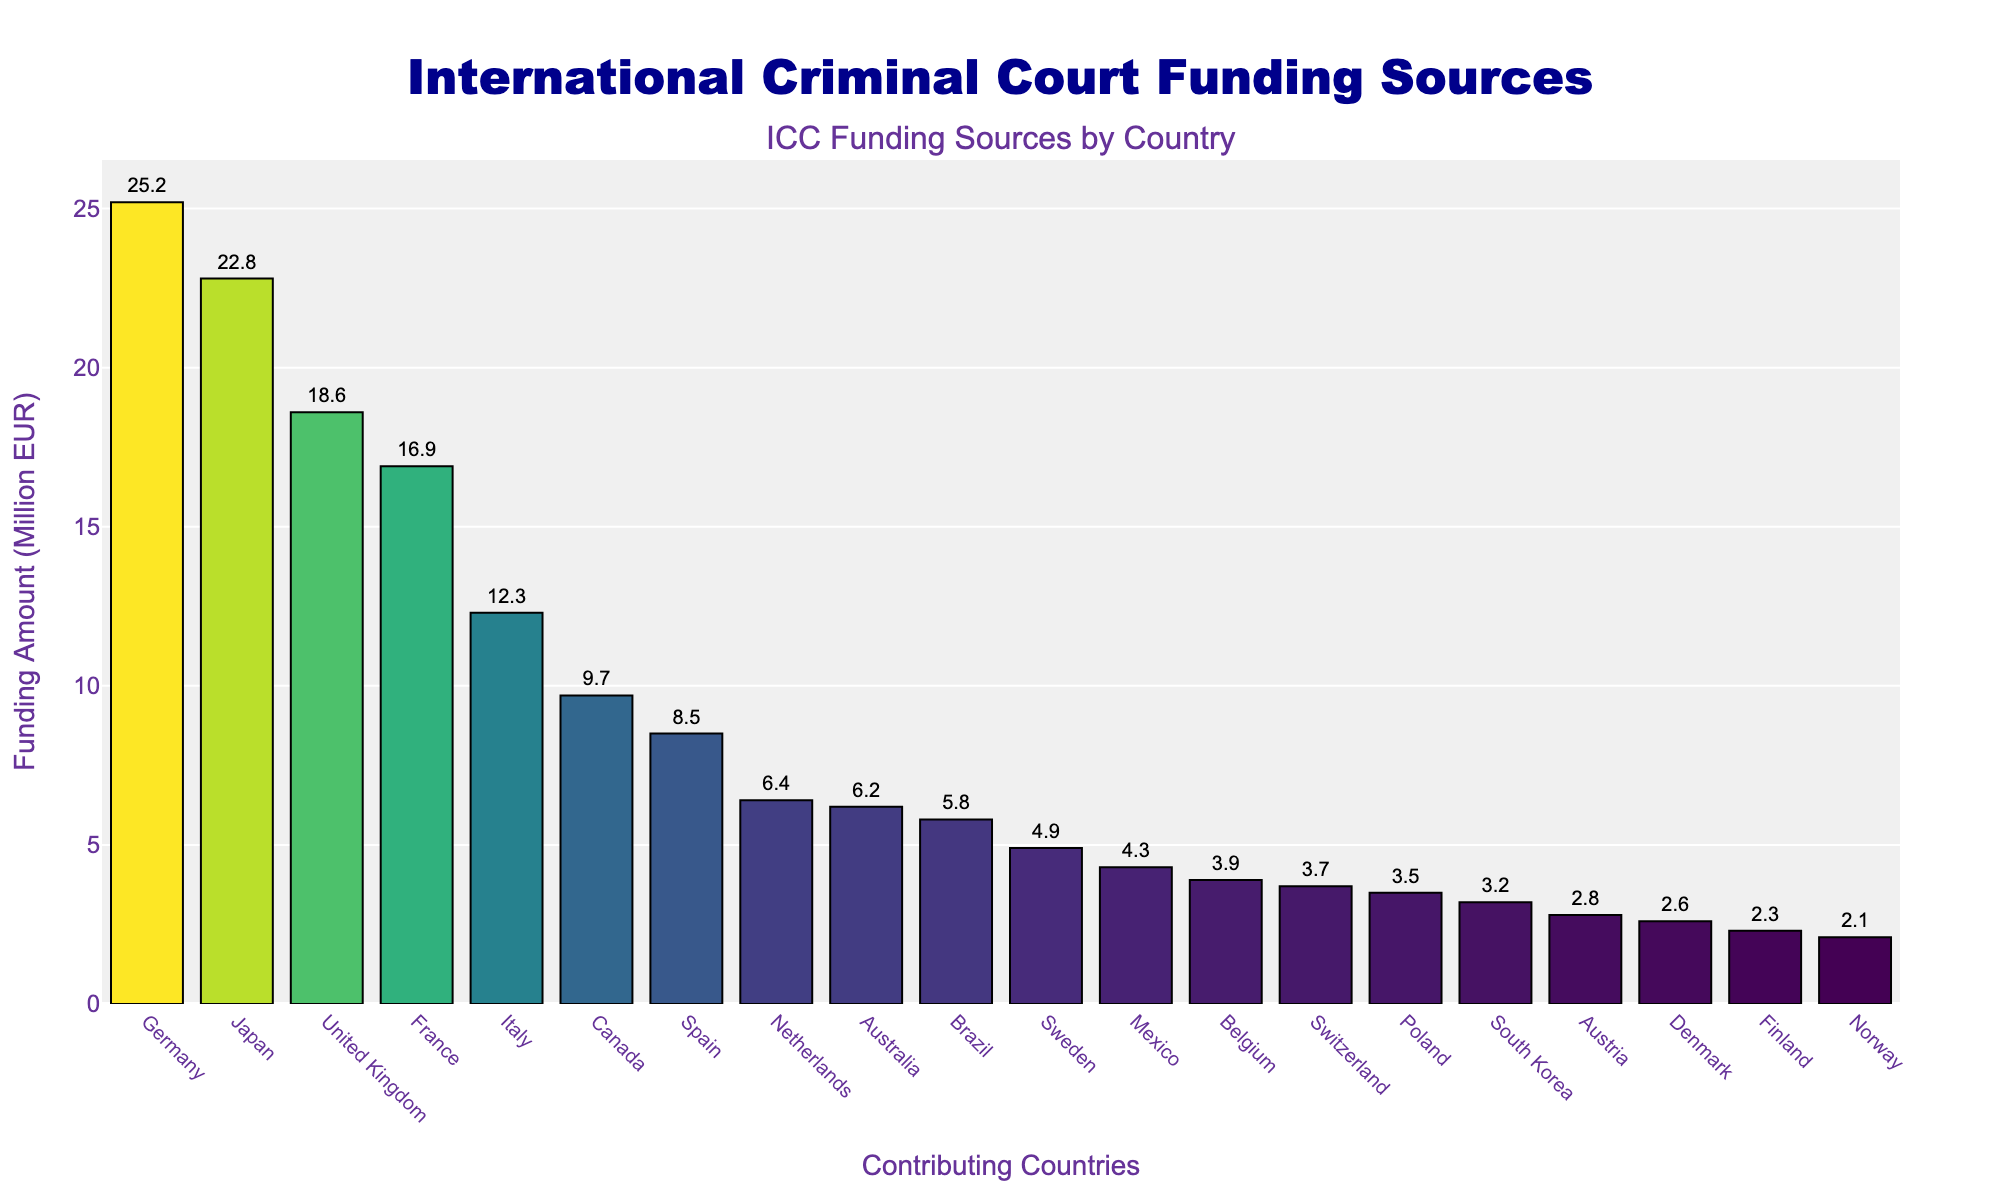Which country contributes the most to the ICC funding? Identify the tallest bar on the chart, as it represents the country with the highest funding. Germany is the country labeled on the tallest bar.
Answer: Germany Which two countries have the closest funding amounts? Look for two bars that are roughly the same height. The bars for Switzerland and Poland are very close in height.
Answer: Switzerland and Poland What is the total funding contributed by Germany and Japan combined? Locate the bars for Germany and Japan, read their funding amounts (25.2 and 22.8 million EUR respectively), and add them together: 25.2 + 22.8 = 48.
Answer: 48 million EUR How does the funding of the United Kingdom compare to that of France? Observe the height of the bars for the United Kingdom and France. The United Kingdom's bar is taller than that of France (18.6 million EUR vs. 16.9 million EUR).
Answer: The United Kingdom provides more funding than France Which country provides the least amount of funding? Identify the shortest bar on the chart, which represents the country with the lowest funding. Norway is the country labeled on this bar.
Answer: Norway What is the average funding amount contributed by the top 5 countries? Identify the top 5 countries (Germany, Japan, United Kingdom, France, Italy) and sum their funding amounts: 25.2 + 22.8 + 18.6 + 16.9 + 12.3 = 95.8. Divide the sum by 5 to find the average: 95.8 / 5 = 19.16 million EUR.
Answer: 19.16 million EUR How much more funding does Italy contribute compared to Switzerland? Find the funding amounts for Italy (12.3 million EUR) and Switzerland (3.7 million EUR). Subtract Switzerland's funding from Italy's: 12.3 - 3.7 = 8.6.
Answer: 8.6 million EUR Which country is immediately after Belgium in terms of funding amount? Arrange the countries by funding amount in descending order. Belgium (3.9 million EUR) is followed by Switzerland (3.7 million EUR).
Answer: Switzerland What is the combined funding of the countries contributing less than 5 million EUR each? Identify countries with funding less than 5 million EUR (Sweden, Mexico, Belgium, Switzerland, Poland, South Korea, Austria, Denmark, Finland, Norway) and sum their amounts: 4.9 + 4.3 + 3.9 + 3.7 + 3.5 + 3.2 + 2.8 + 2.6 + 2.3 + 2.1 = 33.3 million EUR.
Answer: 33.3 million EUR Which country contributes €9.7 million to the ICC fund? Locate the bar with a label of 9.7 million EUR. The corresponding country is Canada.
Answer: Canada 